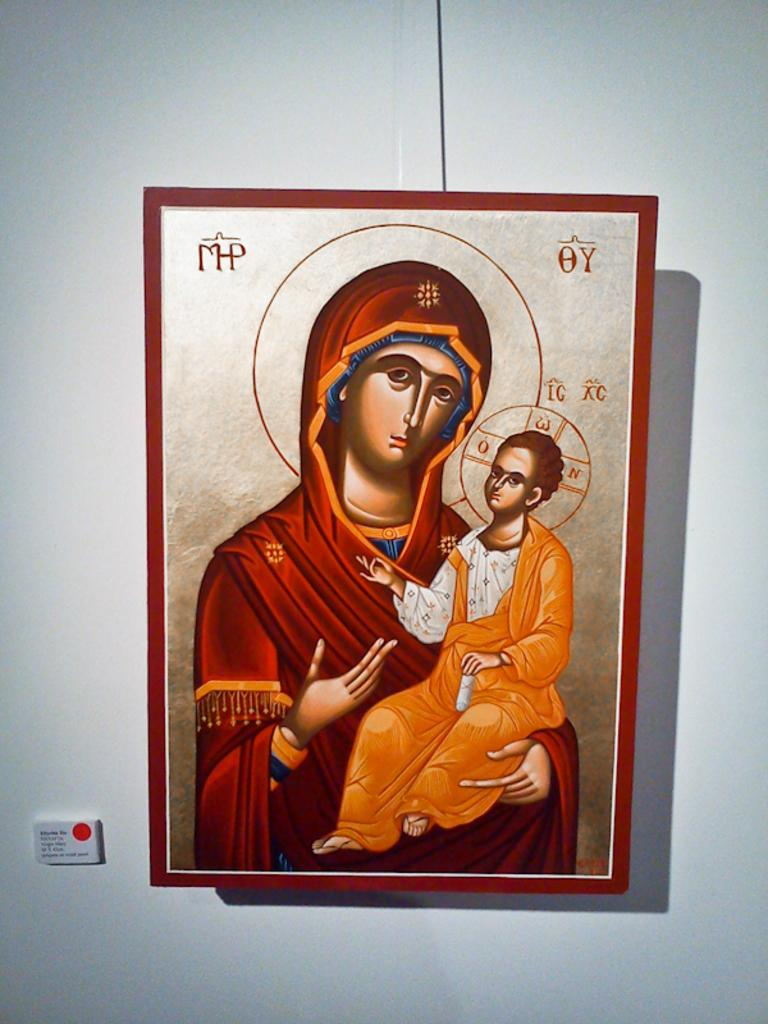What object is present in the image that typically holds a photograph? There is a photo frame in the image. What is depicted in the photo frame? The photo frame contains an image of a woman. What is happening in the image within the photo frame? A boy is being held in the image. What color is the wall on which the photo frame is hanging? The photo frame is hanging on a white-colored wall. What type of rhythm is the woman in the photo frame dancing to? There is no indication of dancing or rhythm in the image; it only shows a woman in a photo frame. 